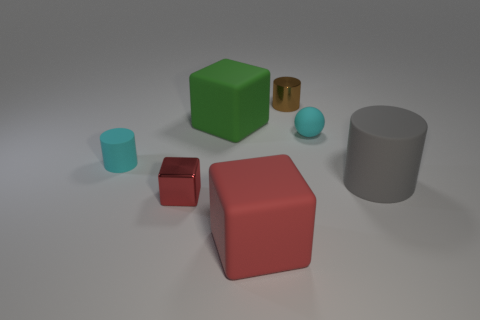Add 3 small red metal things. How many objects exist? 10 Subtract 2 cylinders. How many cylinders are left? 1 Subtract all red metal blocks. How many blocks are left? 2 Subtract all red blocks. How many blocks are left? 1 Subtract all balls. How many objects are left? 6 Subtract all blue blocks. Subtract all yellow balls. How many blocks are left? 3 Subtract all yellow cubes. How many cyan cylinders are left? 1 Subtract all tiny red metallic blocks. Subtract all large cubes. How many objects are left? 4 Add 1 tiny cubes. How many tiny cubes are left? 2 Add 7 small purple metal things. How many small purple metal things exist? 7 